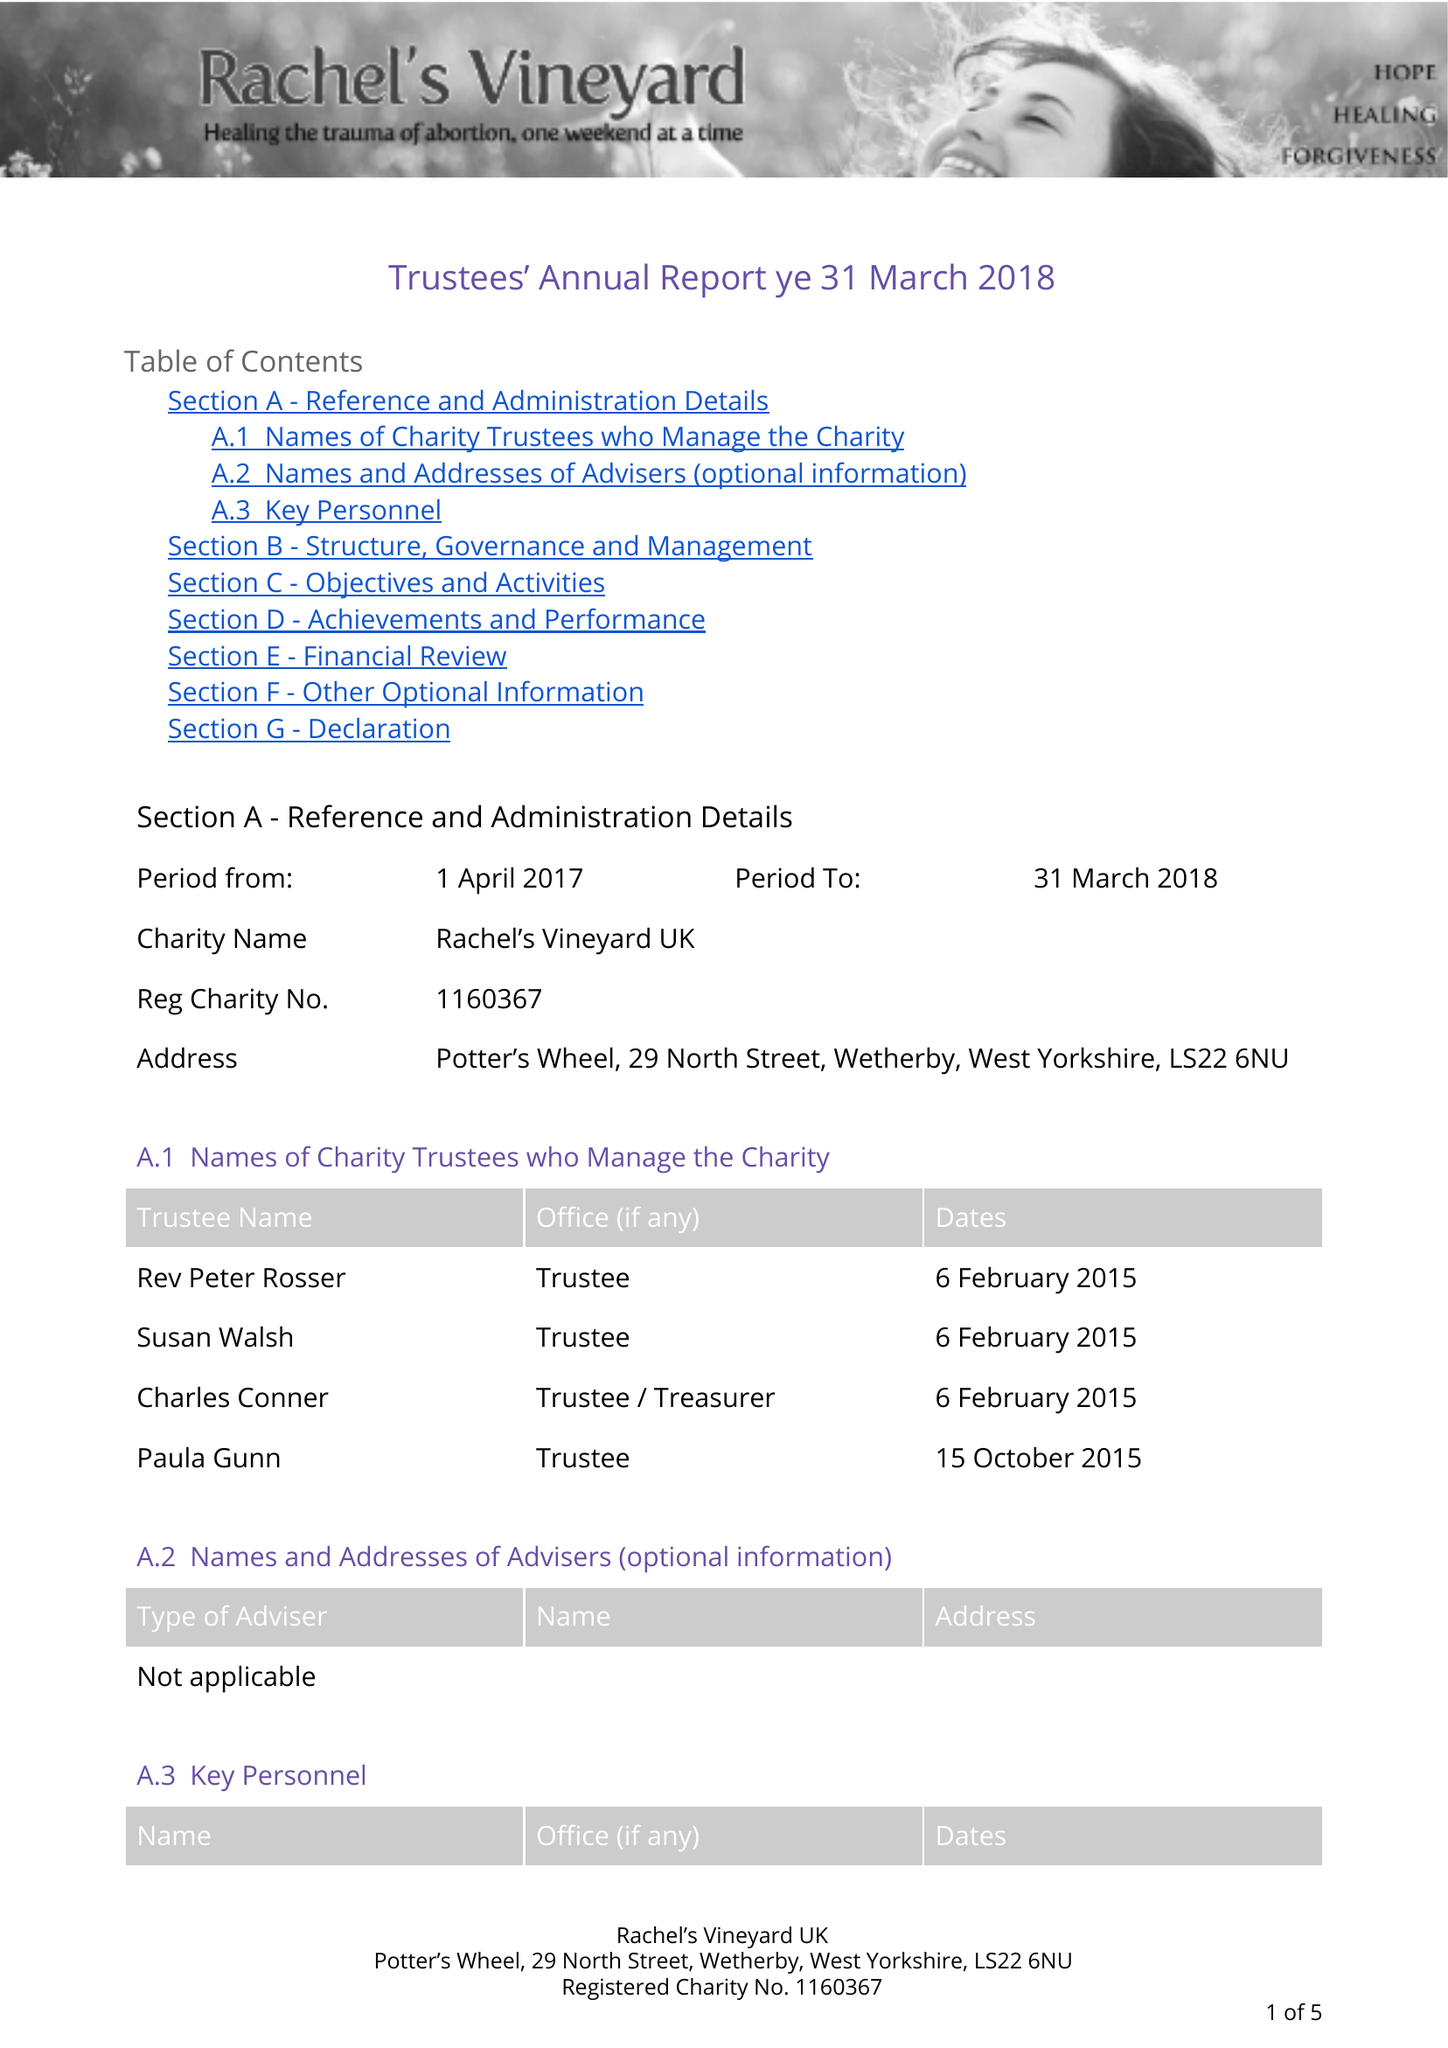What is the value for the address__postcode?
Answer the question using a single word or phrase. LS22 6NX 